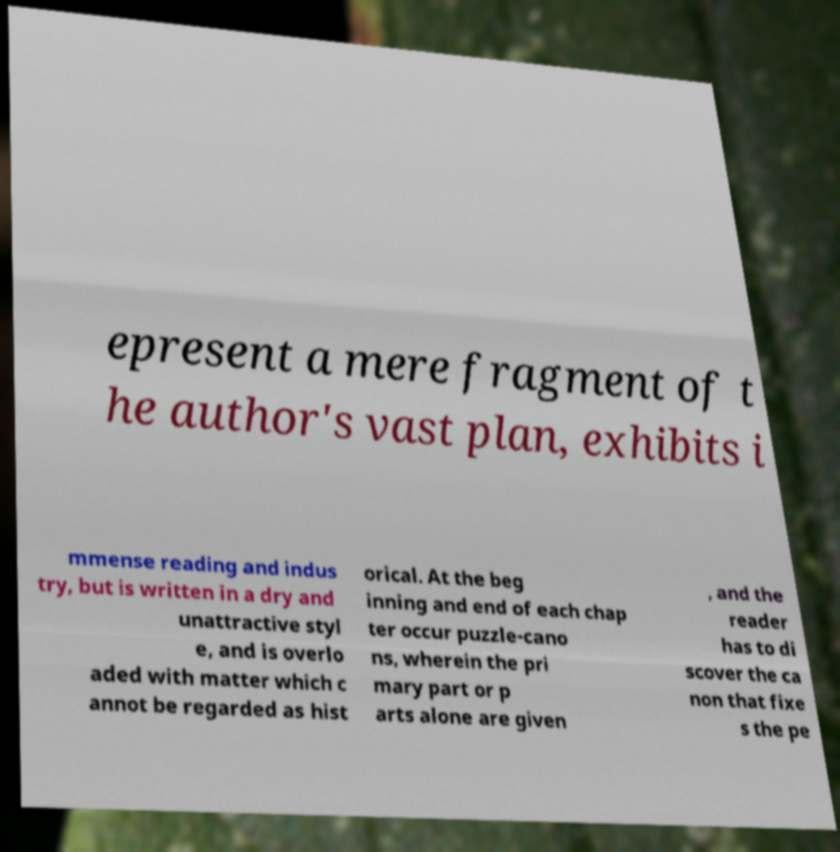Can you accurately transcribe the text from the provided image for me? epresent a mere fragment of t he author's vast plan, exhibits i mmense reading and indus try, but is written in a dry and unattractive styl e, and is overlo aded with matter which c annot be regarded as hist orical. At the beg inning and end of each chap ter occur puzzle-cano ns, wherein the pri mary part or p arts alone are given , and the reader has to di scover the ca non that fixe s the pe 